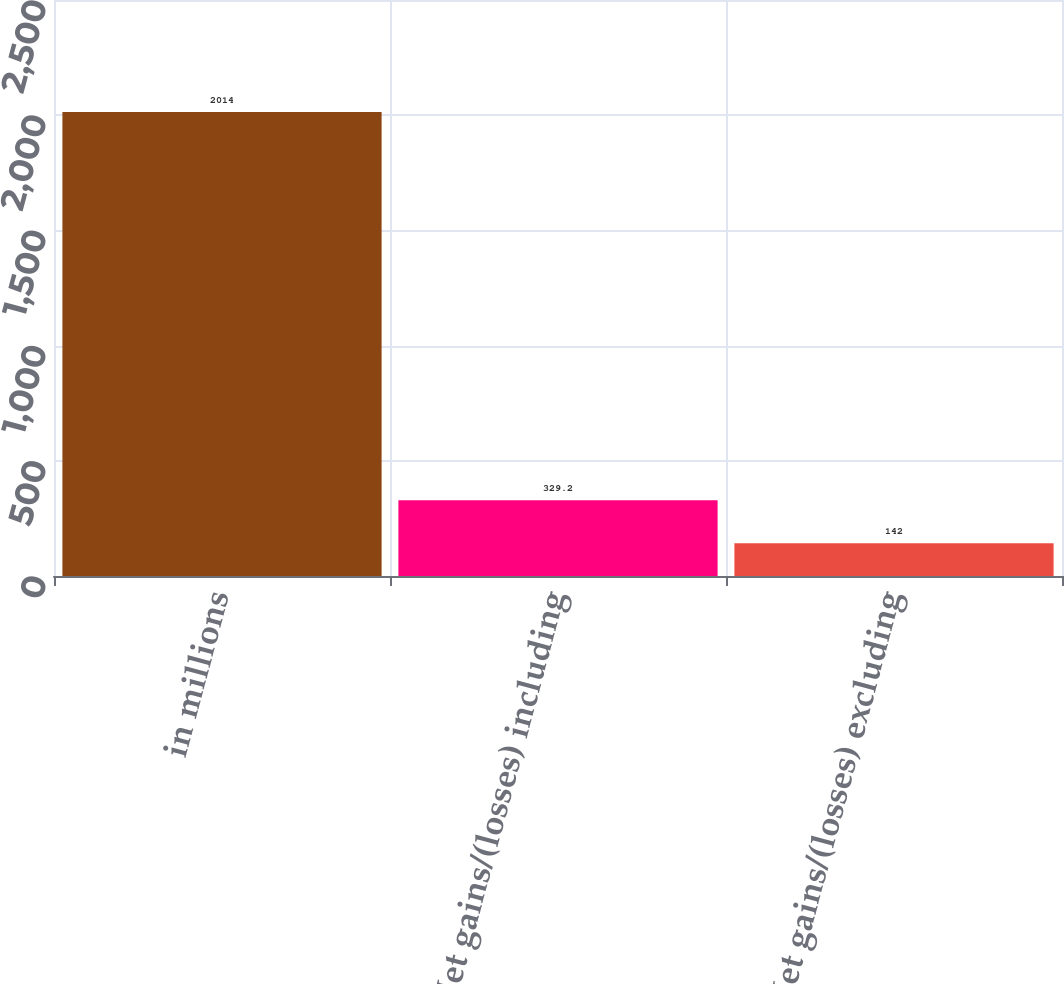<chart> <loc_0><loc_0><loc_500><loc_500><bar_chart><fcel>in millions<fcel>Net gains/(losses) including<fcel>Net gains/(losses) excluding<nl><fcel>2014<fcel>329.2<fcel>142<nl></chart> 